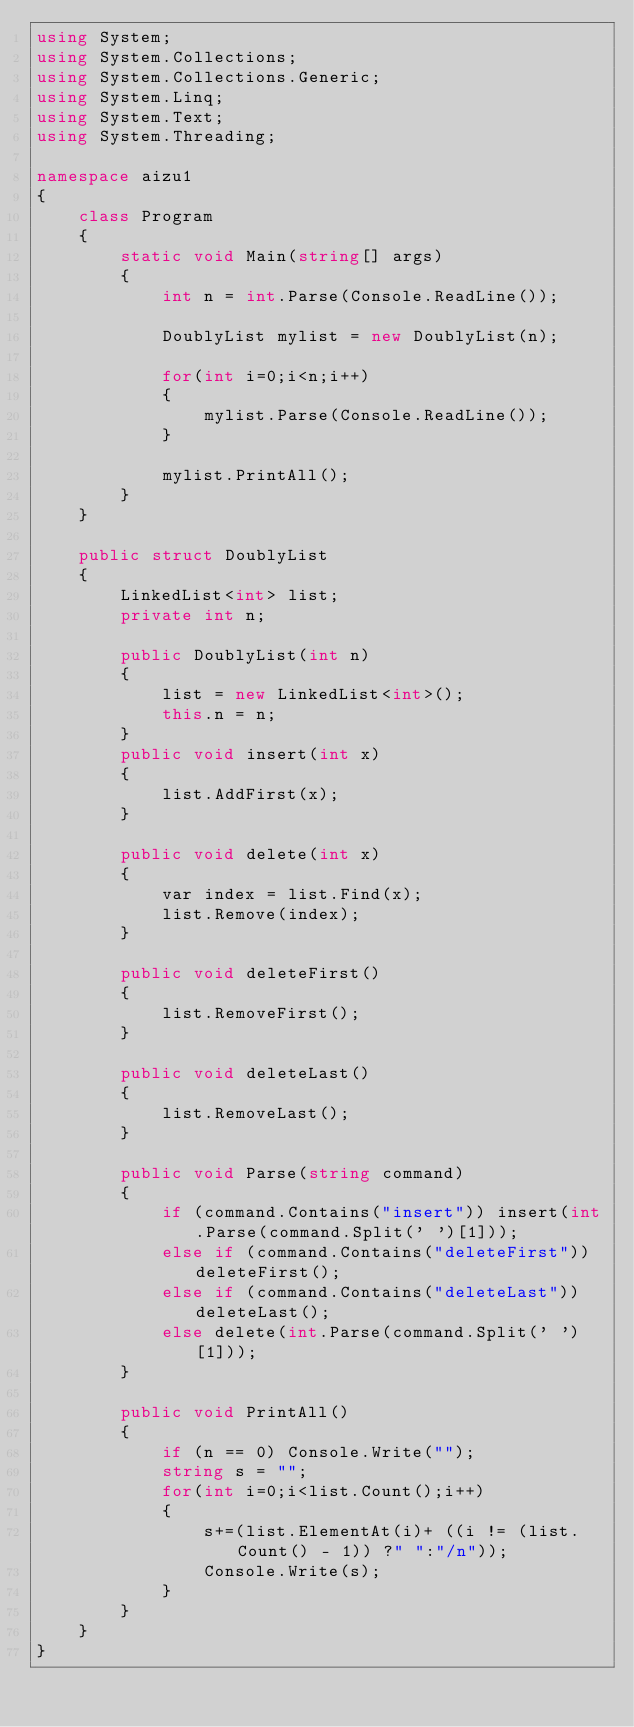Convert code to text. <code><loc_0><loc_0><loc_500><loc_500><_C#_>using System;
using System.Collections;
using System.Collections.Generic;
using System.Linq;
using System.Text;
using System.Threading;

namespace aizu1
{
    class Program
    {
        static void Main(string[] args)
        {
            int n = int.Parse(Console.ReadLine());

            DoublyList mylist = new DoublyList(n);

            for(int i=0;i<n;i++)
            {
                mylist.Parse(Console.ReadLine());
            }

            mylist.PrintAll();
        }
    }

    public struct DoublyList
    {
        LinkedList<int> list;
        private int n;

        public DoublyList(int n)
        {
            list = new LinkedList<int>();
            this.n = n;
        }
        public void insert(int x)
        {
            list.AddFirst(x);
        }

        public void delete(int x)
        {
            var index = list.Find(x);
            list.Remove(index);
        }

        public void deleteFirst()
        {
            list.RemoveFirst();
        }

        public void deleteLast()
        {
            list.RemoveLast();
        }

        public void Parse(string command)
        {
            if (command.Contains("insert")) insert(int.Parse(command.Split(' ')[1]));
            else if (command.Contains("deleteFirst")) deleteFirst();
            else if (command.Contains("deleteLast")) deleteLast();
            else delete(int.Parse(command.Split(' ')[1]));
        }

        public void PrintAll()
        {
            if (n == 0) Console.Write("");
            string s = "";
            for(int i=0;i<list.Count();i++)
            {
                s+=(list.ElementAt(i)+ ((i != (list.Count() - 1)) ?" ":"/n"));
                Console.Write(s);
            }
        }
    }
}</code> 